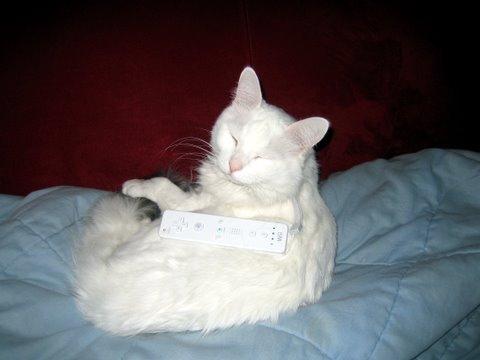What is shining on the cat's paws?
Be succinct. Nothing. Is the cat the same color as the sofa?
Keep it brief. No. For the photo on the right, are the cat's eyes open or closed?
Be succinct. Closed. Is there a mouse?
Give a very brief answer. No. Is the cat asleep?
Concise answer only. Yes. How many cat's paw can you see?
Keep it brief. 1. Is the cat trying to use the remote control?
Quick response, please. No. Is the sheet white?
Answer briefly. No. What color are the sheets?
Quick response, please. Blue. How many cats are there?
Short answer required. 1. What is the cat lying on?
Concise answer only. Blanket. What color is the couch?
Be succinct. Red. Is the animal in the photo partially hidden?
Keep it brief. No. 